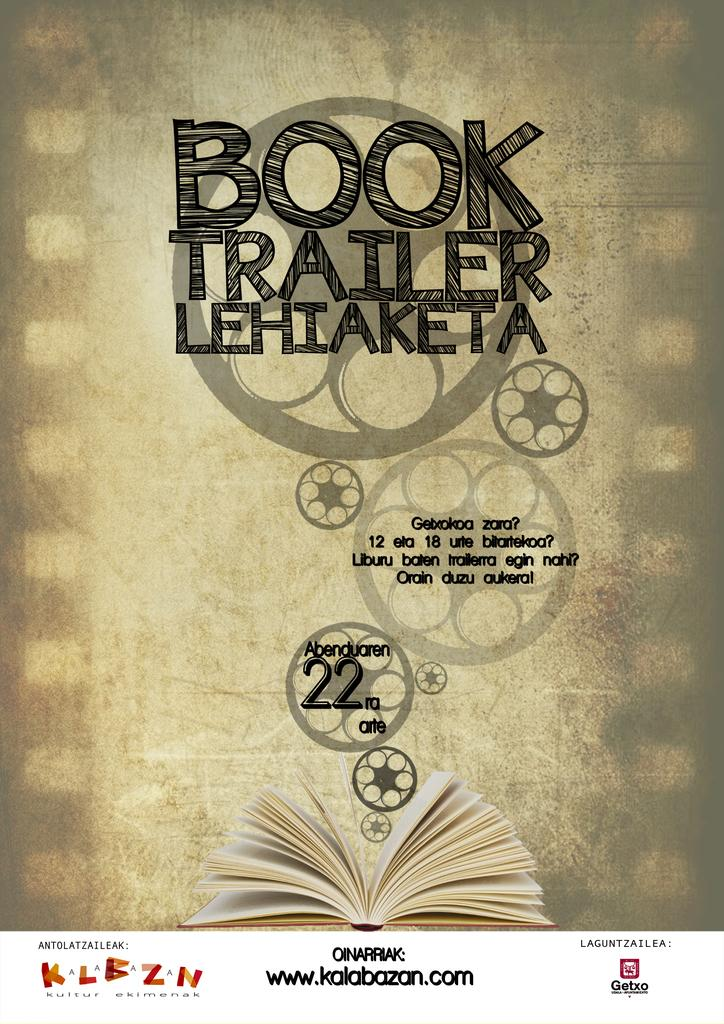<image>
Summarize the visual content of the image. a picture with mostly tan and black writing and a website www.kalabazan.com at the bottom 